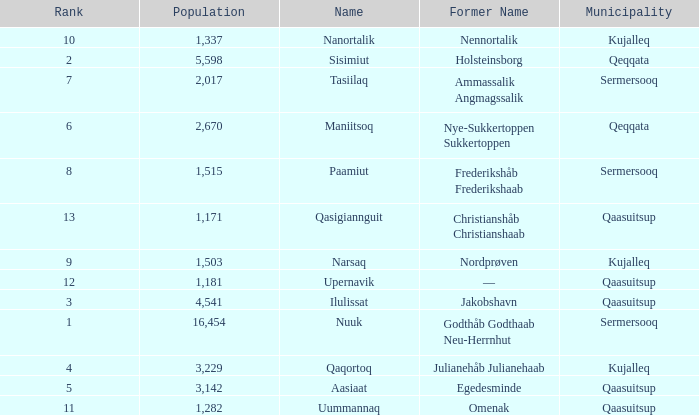What is the population for Rank 11? 1282.0. 